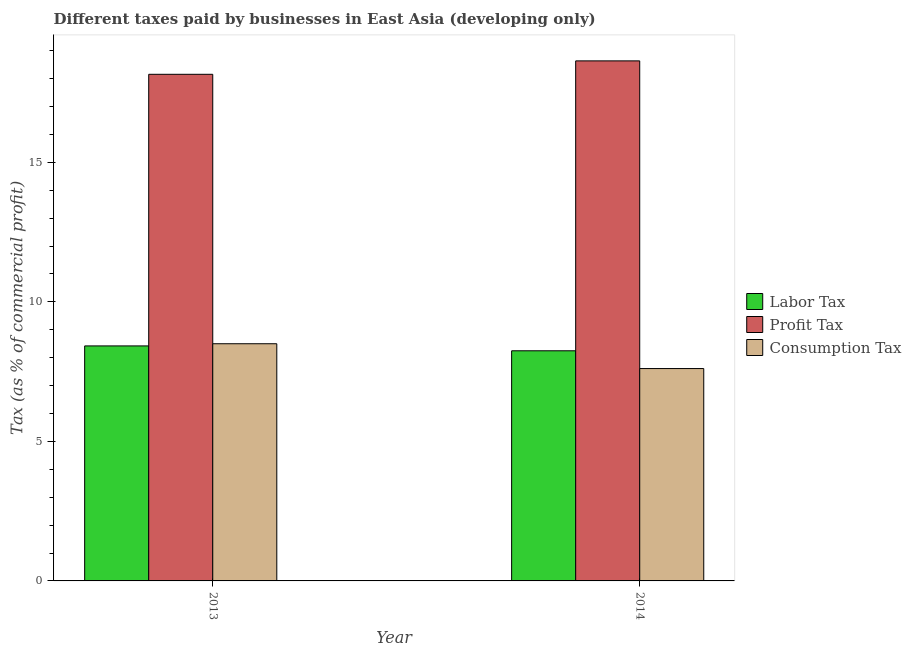How many different coloured bars are there?
Ensure brevity in your answer.  3. Are the number of bars per tick equal to the number of legend labels?
Keep it short and to the point. Yes. Are the number of bars on each tick of the X-axis equal?
Offer a terse response. Yes. How many bars are there on the 2nd tick from the left?
Provide a succinct answer. 3. How many bars are there on the 2nd tick from the right?
Make the answer very short. 3. In how many cases, is the number of bars for a given year not equal to the number of legend labels?
Give a very brief answer. 0. What is the percentage of consumption tax in 2014?
Provide a succinct answer. 7.61. Across all years, what is the maximum percentage of consumption tax?
Give a very brief answer. 8.5. Across all years, what is the minimum percentage of labor tax?
Make the answer very short. 8.25. In which year was the percentage of labor tax minimum?
Offer a very short reply. 2014. What is the total percentage of consumption tax in the graph?
Offer a terse response. 16.11. What is the difference between the percentage of labor tax in 2013 and that in 2014?
Provide a short and direct response. 0.17. What is the difference between the percentage of consumption tax in 2014 and the percentage of profit tax in 2013?
Keep it short and to the point. -0.89. What is the average percentage of consumption tax per year?
Provide a short and direct response. 8.06. In the year 2013, what is the difference between the percentage of consumption tax and percentage of profit tax?
Provide a short and direct response. 0. In how many years, is the percentage of profit tax greater than 6 %?
Your response must be concise. 2. What is the ratio of the percentage of labor tax in 2013 to that in 2014?
Keep it short and to the point. 1.02. In how many years, is the percentage of labor tax greater than the average percentage of labor tax taken over all years?
Your response must be concise. 1. What does the 3rd bar from the left in 2013 represents?
Provide a short and direct response. Consumption Tax. What does the 2nd bar from the right in 2013 represents?
Offer a terse response. Profit Tax. Are all the bars in the graph horizontal?
Your answer should be compact. No. How many years are there in the graph?
Provide a succinct answer. 2. Are the values on the major ticks of Y-axis written in scientific E-notation?
Offer a terse response. No. Does the graph contain grids?
Give a very brief answer. No. How many legend labels are there?
Offer a very short reply. 3. What is the title of the graph?
Make the answer very short. Different taxes paid by businesses in East Asia (developing only). What is the label or title of the X-axis?
Your answer should be compact. Year. What is the label or title of the Y-axis?
Your response must be concise. Tax (as % of commercial profit). What is the Tax (as % of commercial profit) in Labor Tax in 2013?
Ensure brevity in your answer.  8.42. What is the Tax (as % of commercial profit) of Profit Tax in 2013?
Ensure brevity in your answer.  18.16. What is the Tax (as % of commercial profit) in Consumption Tax in 2013?
Make the answer very short. 8.5. What is the Tax (as % of commercial profit) in Labor Tax in 2014?
Make the answer very short. 8.25. What is the Tax (as % of commercial profit) of Profit Tax in 2014?
Your response must be concise. 18.64. What is the Tax (as % of commercial profit) in Consumption Tax in 2014?
Give a very brief answer. 7.61. Across all years, what is the maximum Tax (as % of commercial profit) in Labor Tax?
Your response must be concise. 8.42. Across all years, what is the maximum Tax (as % of commercial profit) of Profit Tax?
Make the answer very short. 18.64. Across all years, what is the minimum Tax (as % of commercial profit) in Labor Tax?
Provide a succinct answer. 8.25. Across all years, what is the minimum Tax (as % of commercial profit) in Profit Tax?
Provide a short and direct response. 18.16. Across all years, what is the minimum Tax (as % of commercial profit) of Consumption Tax?
Your answer should be compact. 7.61. What is the total Tax (as % of commercial profit) of Labor Tax in the graph?
Your response must be concise. 16.67. What is the total Tax (as % of commercial profit) in Profit Tax in the graph?
Ensure brevity in your answer.  36.79. What is the total Tax (as % of commercial profit) in Consumption Tax in the graph?
Offer a terse response. 16.11. What is the difference between the Tax (as % of commercial profit) in Labor Tax in 2013 and that in 2014?
Make the answer very short. 0.17. What is the difference between the Tax (as % of commercial profit) in Profit Tax in 2013 and that in 2014?
Your answer should be very brief. -0.48. What is the difference between the Tax (as % of commercial profit) in Consumption Tax in 2013 and that in 2014?
Offer a terse response. 0.89. What is the difference between the Tax (as % of commercial profit) in Labor Tax in 2013 and the Tax (as % of commercial profit) in Profit Tax in 2014?
Give a very brief answer. -10.21. What is the difference between the Tax (as % of commercial profit) in Labor Tax in 2013 and the Tax (as % of commercial profit) in Consumption Tax in 2014?
Offer a very short reply. 0.81. What is the difference between the Tax (as % of commercial profit) of Profit Tax in 2013 and the Tax (as % of commercial profit) of Consumption Tax in 2014?
Give a very brief answer. 10.54. What is the average Tax (as % of commercial profit) of Labor Tax per year?
Your answer should be compact. 8.33. What is the average Tax (as % of commercial profit) of Profit Tax per year?
Provide a short and direct response. 18.4. What is the average Tax (as % of commercial profit) of Consumption Tax per year?
Keep it short and to the point. 8.06. In the year 2013, what is the difference between the Tax (as % of commercial profit) in Labor Tax and Tax (as % of commercial profit) in Profit Tax?
Ensure brevity in your answer.  -9.73. In the year 2013, what is the difference between the Tax (as % of commercial profit) of Labor Tax and Tax (as % of commercial profit) of Consumption Tax?
Keep it short and to the point. -0.08. In the year 2013, what is the difference between the Tax (as % of commercial profit) in Profit Tax and Tax (as % of commercial profit) in Consumption Tax?
Give a very brief answer. 9.66. In the year 2014, what is the difference between the Tax (as % of commercial profit) of Labor Tax and Tax (as % of commercial profit) of Profit Tax?
Provide a succinct answer. -10.39. In the year 2014, what is the difference between the Tax (as % of commercial profit) in Labor Tax and Tax (as % of commercial profit) in Consumption Tax?
Provide a succinct answer. 0.64. In the year 2014, what is the difference between the Tax (as % of commercial profit) of Profit Tax and Tax (as % of commercial profit) of Consumption Tax?
Offer a terse response. 11.03. What is the ratio of the Tax (as % of commercial profit) of Labor Tax in 2013 to that in 2014?
Make the answer very short. 1.02. What is the ratio of the Tax (as % of commercial profit) of Profit Tax in 2013 to that in 2014?
Your response must be concise. 0.97. What is the ratio of the Tax (as % of commercial profit) of Consumption Tax in 2013 to that in 2014?
Make the answer very short. 1.12. What is the difference between the highest and the second highest Tax (as % of commercial profit) in Labor Tax?
Provide a short and direct response. 0.17. What is the difference between the highest and the second highest Tax (as % of commercial profit) of Profit Tax?
Your answer should be very brief. 0.48. What is the difference between the highest and the second highest Tax (as % of commercial profit) of Consumption Tax?
Provide a short and direct response. 0.89. What is the difference between the highest and the lowest Tax (as % of commercial profit) of Labor Tax?
Offer a very short reply. 0.17. What is the difference between the highest and the lowest Tax (as % of commercial profit) of Profit Tax?
Offer a very short reply. 0.48. What is the difference between the highest and the lowest Tax (as % of commercial profit) in Consumption Tax?
Your answer should be compact. 0.89. 